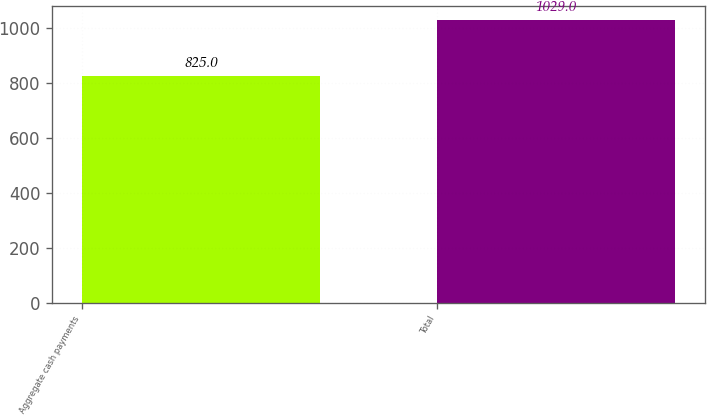Convert chart. <chart><loc_0><loc_0><loc_500><loc_500><bar_chart><fcel>Aggregate cash payments<fcel>Total<nl><fcel>825<fcel>1029<nl></chart> 